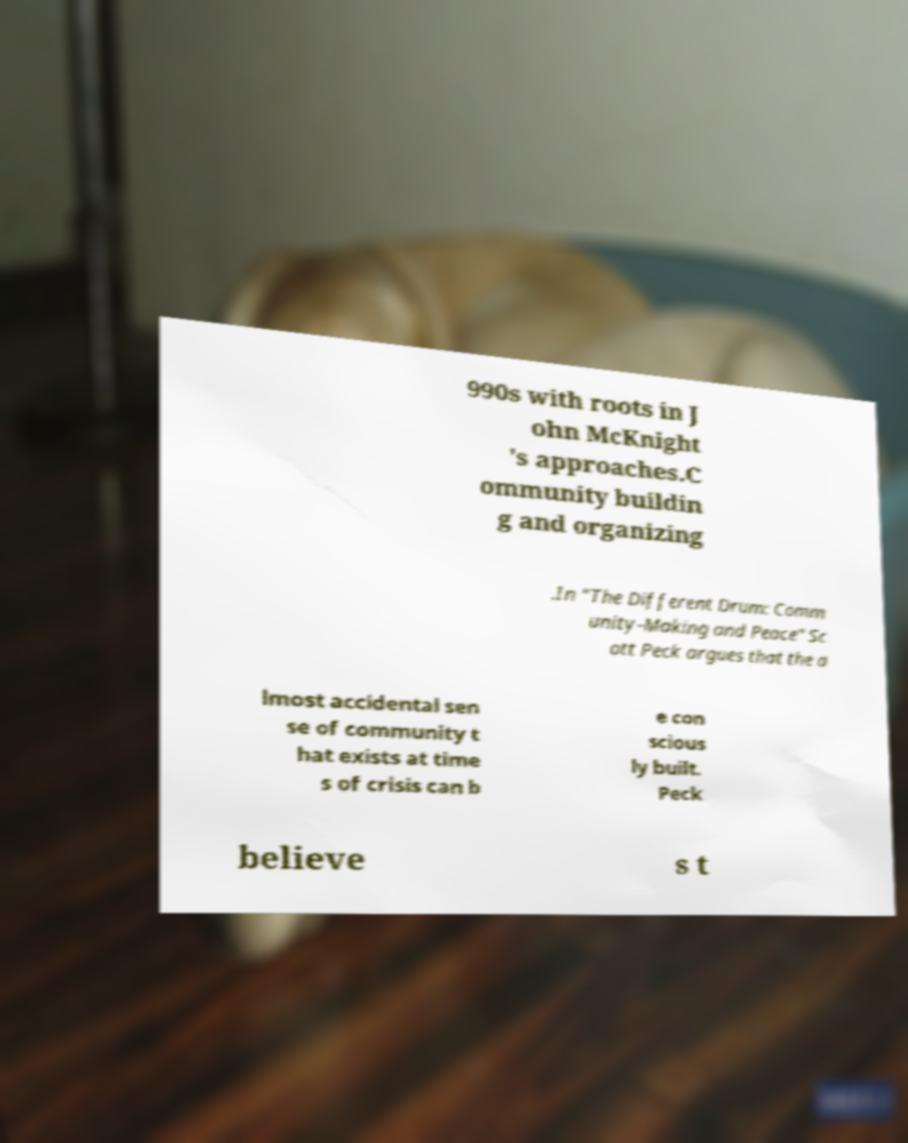Could you assist in decoding the text presented in this image and type it out clearly? 990s with roots in J ohn McKnight 's approaches.C ommunity buildin g and organizing .In "The Different Drum: Comm unity-Making and Peace" Sc ott Peck argues that the a lmost accidental sen se of community t hat exists at time s of crisis can b e con scious ly built. Peck believe s t 